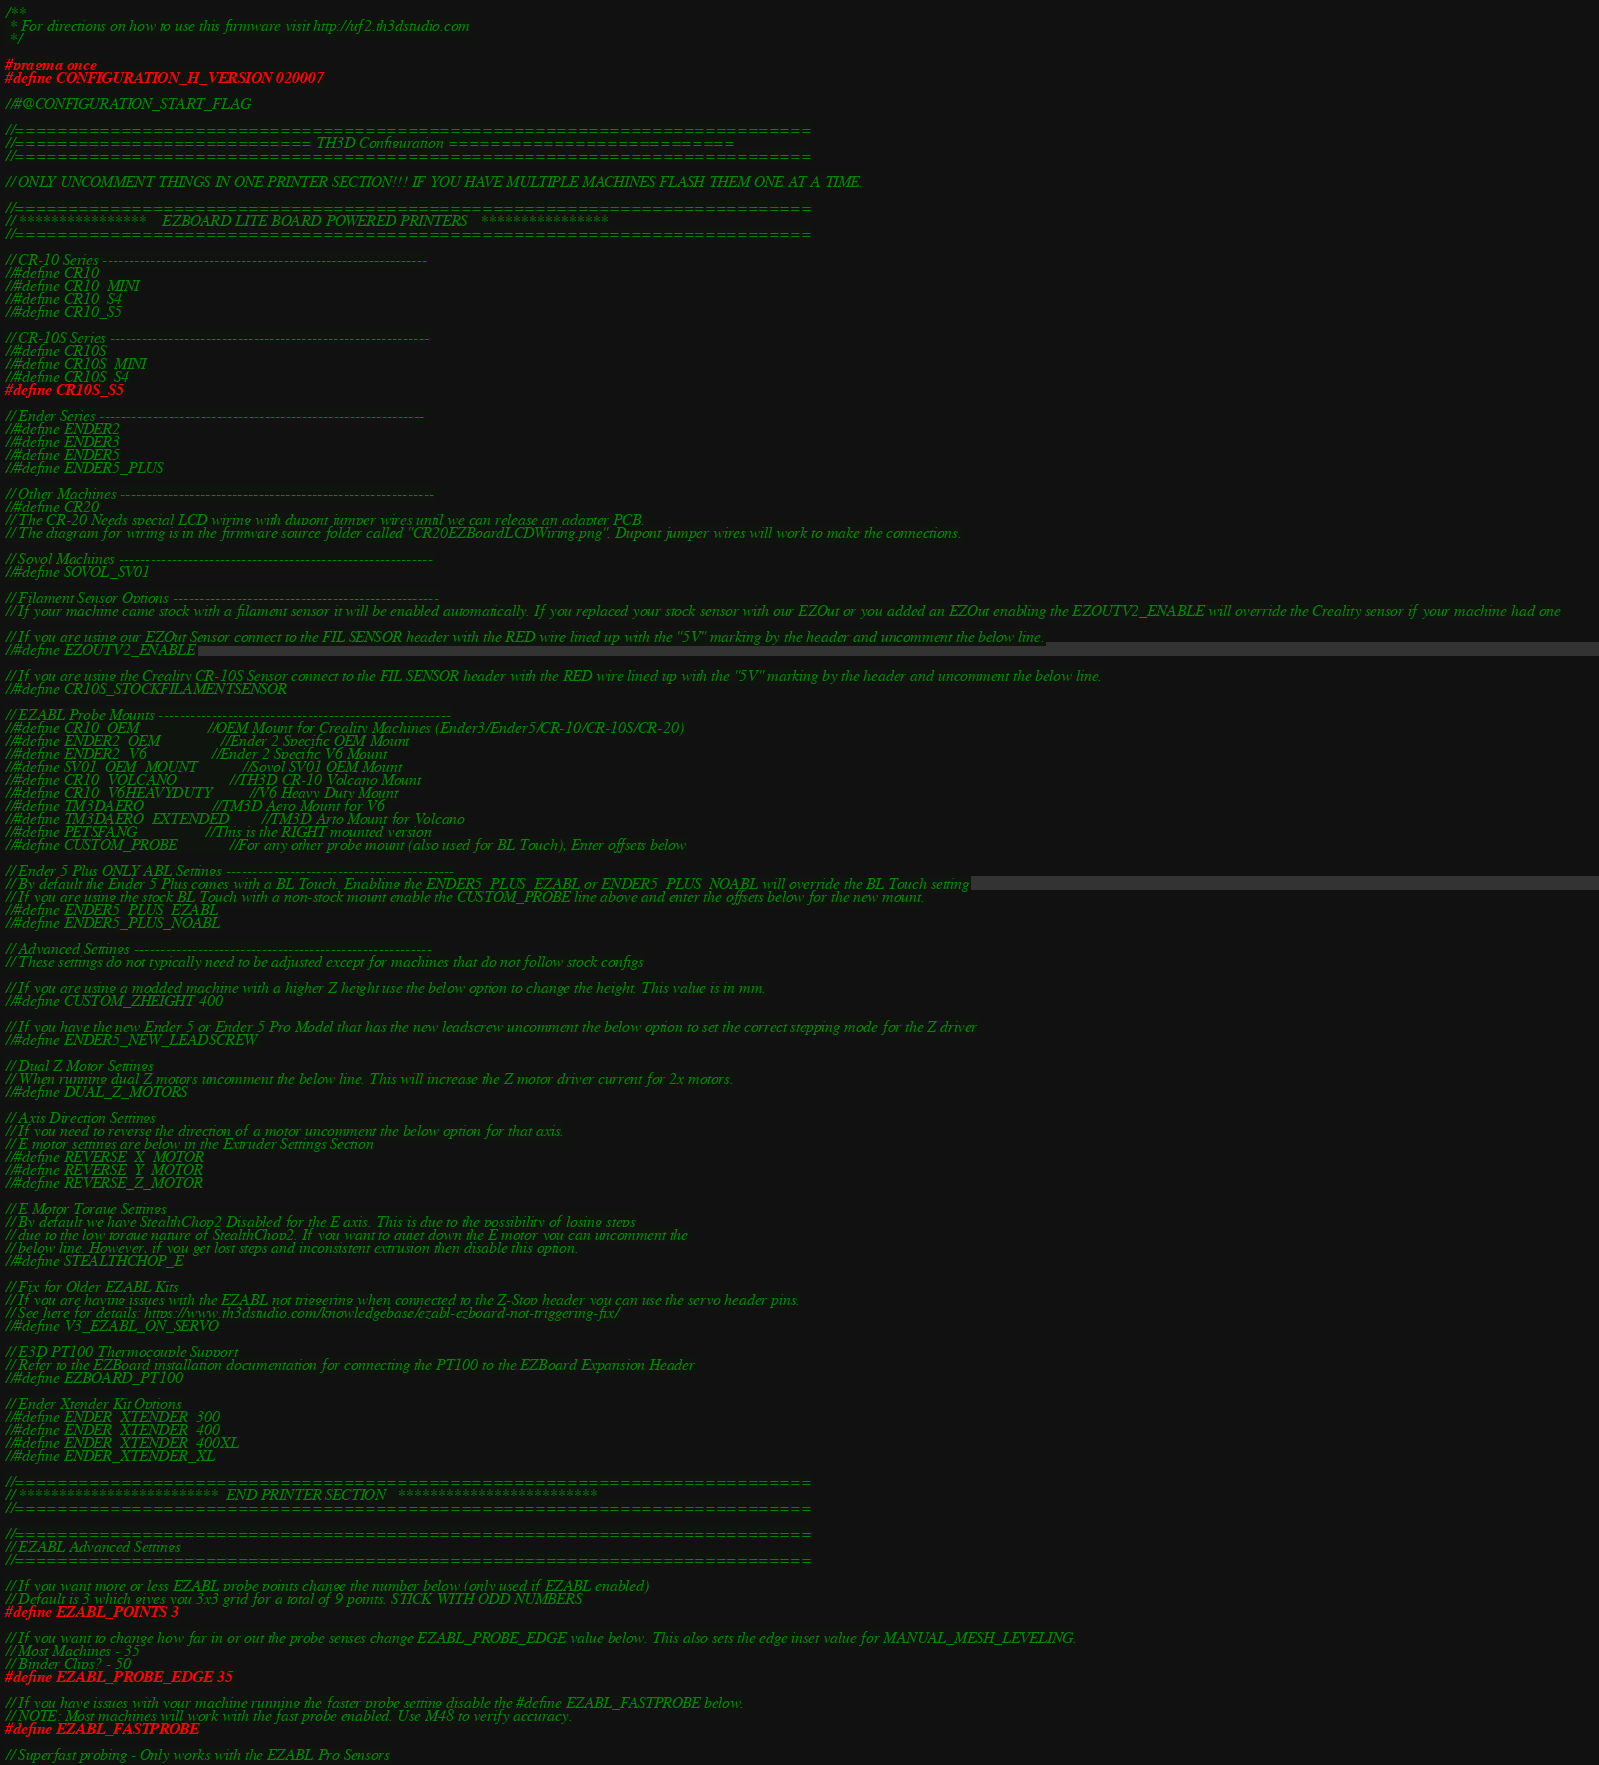Convert code to text. <code><loc_0><loc_0><loc_500><loc_500><_C_>/**
 * For directions on how to use this firmware visit http://uf2.th3dstudio.com
 */

#pragma once
#define CONFIGURATION_H_VERSION 020007

//#@CONFIGURATION_START_FLAG

//===========================================================================
//============================ TH3D Configuration ===========================
//===========================================================================

// ONLY UNCOMMENT THINGS IN ONE PRINTER SECTION!!! IF YOU HAVE MULTIPLE MACHINES FLASH THEM ONE AT A TIME.

//===========================================================================
// ****************    EZBOARD LITE BOARD POWERED PRINTERS   ****************
//===========================================================================

// CR-10 Series -------------------------------------------------------------
//#define CR10
//#define CR10_MINI
//#define CR10_S4
//#define CR10_S5

// CR-10S Series ------------------------------------------------------------
//#define CR10S
//#define CR10S_MINI
//#define CR10S_S4
#define CR10S_S5

// Ender Series -------------------------------------------------------------
//#define ENDER2
//#define ENDER3
//#define ENDER5
//#define ENDER5_PLUS

// Other Machines -----------------------------------------------------------
//#define CR20
// The CR-20 Needs special LCD wiring with dupont jumper wires until we can release an adapter PCB.
// The diagram for wiring is in the firmware source folder called "CR20EZBoardLCDWiring.png". Dupont jumper wires will work to make the connections.

// Sovol Machines -----------------------------------------------------------
//#define SOVOL_SV01

// Filament Sensor Options --------------------------------------------------
// If your machine came stock with a filament sensor it will be enabled automatically. If you replaced your stock sensor with our EZOut or you added an EZOut enabling the EZOUTV2_ENABLE will override the Creality sensor if your machine had one

// If you are using our EZOut Sensor connect to the FIL SENSOR header with the RED wire lined up with the "5V" marking by the header and uncomment the below line.
//#define EZOUTV2_ENABLE

// If you are using the Creality CR-10S Sensor connect to the FIL SENSOR header with the RED wire lined up with the "5V" marking by the header and uncomment the below line.
//#define CR10S_STOCKFILAMENTSENSOR

// EZABL Probe Mounts -------------------------------------------------------
//#define CR10_OEM                 //OEM Mount for Creality Machines (Ender3/Ender5/CR-10/CR-10S/CR-20)
//#define ENDER2_OEM               //Ender 2 Specific OEM Mount
//#define ENDER2_V6                //Ender 2 Specific V6 Mount
//#define SV01_OEM_MOUNT           //Sovol SV01 OEM Mount
//#define CR10_VOLCANO             //TH3D CR-10 Volcano Mount 
//#define CR10_V6HEAVYDUTY         //V6 Heavy Duty Mount
//#define TM3DAERO                 //TM3D Aero Mount for V6
//#define TM3DAERO_EXTENDED        //TM3D Arto Mount for Volcano
//#define PETSFANG                 //This is the RIGHT mounted version
//#define CUSTOM_PROBE             //For any other probe mount (also used for BL Touch), Enter offsets below

// Ender 5 Plus ONLY ABL Settings -------------------------------------------
// By default the Ender 5 Plus comes with a BL Touch. Enabling the ENDER5_PLUS_EZABL or ENDER5_PLUS_NOABL will override the BL Touch setting
// If you are using the stock BL Touch with a non-stock mount enable the CUSTOM_PROBE line above and enter the offsets below for the new mount.
//#define ENDER5_PLUS_EZABL
//#define ENDER5_PLUS_NOABL

// Advanced Settings --------------------------------------------------------
// These settings do not typically need to be adjusted except for machines that do not follow stock configs

// If you are using a modded machine with a higher Z height use the below option to change the height. This value is in mm.
//#define CUSTOM_ZHEIGHT 400

// If you have the new Ender 5 or Ender 5 Pro Model that has the new leadscrew uncomment the below option to set the correct stepping mode for the Z driver
//#define ENDER5_NEW_LEADSCREW

// Dual Z Motor Settings
// When running dual Z motors uncomment the below line. This will increase the Z motor driver current for 2x motors.
//#define DUAL_Z_MOTORS

// Axis Direction Settings
// If you need to reverse the direction of a motor uncomment the below option for that axis.
// E motor settings are below in the Extruder Settings Section
//#define REVERSE_X_MOTOR
//#define REVERSE_Y_MOTOR
//#define REVERSE_Z_MOTOR

// E Motor Torque Settings
// By default we have StealthChop2 Disabled for the E axis. This is due to the possibility of losing steps
// due to the low torque nature of StealthChop2. If you want to quiet down the E motor you can uncomment the
// below line. However, if you get lost steps and inconsistent extrusion then disable this option.
//#define STEALTHCHOP_E

// Fix for Older EZABL Kits
// If you are having issues with the EZABL not triggering when connected to the Z-Stop header you can use the servo header pins.
// See here for details: https://www.th3dstudio.com/knowledgebase/ezabl-ezboard-not-triggering-fix/
//#define V3_EZABL_ON_SERVO

// E3D PT100 Thermocouple Support
// Refer to the EZBoard installation documentation for connecting the PT100 to the EZBoard Expansion Header
//#define EZBOARD_PT100

// Ender Xtender Kit Options
//#define ENDER_XTENDER_300
//#define ENDER_XTENDER_400
//#define ENDER_XTENDER_400XL
//#define ENDER_XTENDER_XL

//===========================================================================
// *************************  END PRINTER SECTION   *************************
//===========================================================================

//===========================================================================
// EZABL Advanced Settings
//===========================================================================

// If you want more or less EZABL probe points change the number below (only used if EZABL enabled)
// Default is 3 which gives you 3x3 grid for a total of 9 points. STICK WITH ODD NUMBERS
#define EZABL_POINTS 3

// If you want to change how far in or out the probe senses change EZABL_PROBE_EDGE value below. This also sets the edge inset value for MANUAL_MESH_LEVELING.
// Most Machines - 35
// Binder Clips? - 50
#define EZABL_PROBE_EDGE 35

// If you have issues with your machine running the faster probe setting disable the #define EZABL_FASTPROBE below.
// NOTE: Most machines will work with the fast probe enabled. Use M48 to verify accuracy.
#define EZABL_FASTPROBE

// Superfast probing - Only works with the EZABL Pro Sensors</code> 